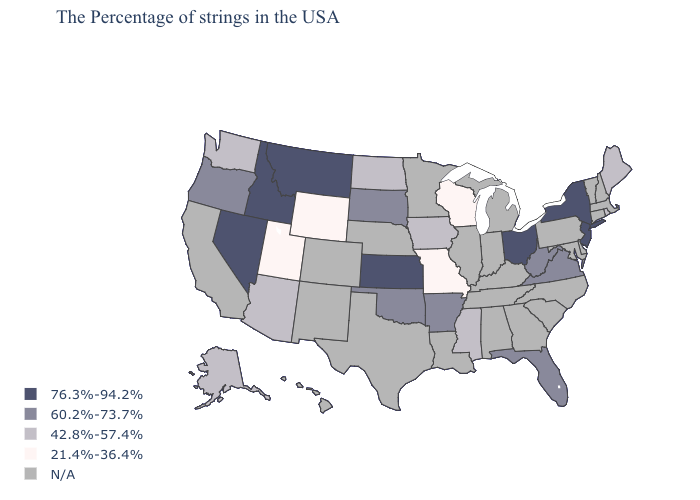Does Utah have the lowest value in the USA?
Give a very brief answer. Yes. Name the states that have a value in the range N/A?
Concise answer only. Massachusetts, New Hampshire, Vermont, Connecticut, Delaware, Maryland, Pennsylvania, North Carolina, South Carolina, Georgia, Michigan, Kentucky, Indiana, Alabama, Tennessee, Illinois, Louisiana, Minnesota, Nebraska, Texas, Colorado, New Mexico, California, Hawaii. Which states have the highest value in the USA?
Give a very brief answer. New York, New Jersey, Ohio, Kansas, Montana, Idaho, Nevada. Does Missouri have the lowest value in the USA?
Write a very short answer. Yes. Among the states that border Louisiana , which have the lowest value?
Concise answer only. Mississippi. What is the highest value in the USA?
Give a very brief answer. 76.3%-94.2%. Which states have the lowest value in the USA?
Give a very brief answer. Wisconsin, Missouri, Wyoming, Utah. What is the value of Nevada?
Quick response, please. 76.3%-94.2%. What is the value of South Carolina?
Keep it brief. N/A. Among the states that border Delaware , which have the lowest value?
Write a very short answer. New Jersey. Among the states that border Oklahoma , does Kansas have the highest value?
Give a very brief answer. Yes. What is the value of Kentucky?
Give a very brief answer. N/A. What is the value of Mississippi?
Be succinct. 42.8%-57.4%. What is the highest value in the USA?
Short answer required. 76.3%-94.2%. 